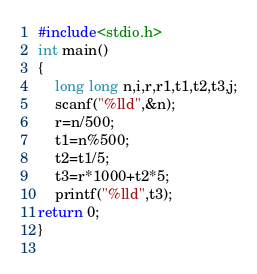<code> <loc_0><loc_0><loc_500><loc_500><_C_>#include<stdio.h>
int main()
{
	long long n,i,r,r1,t1,t2,t3,j;
	scanf("%lld",&n);
	r=n/500;
	t1=n%500;
	t2=t1/5;
	t3=r*1000+t2*5;
	printf("%lld",t3);
return 0;
}
	</code> 